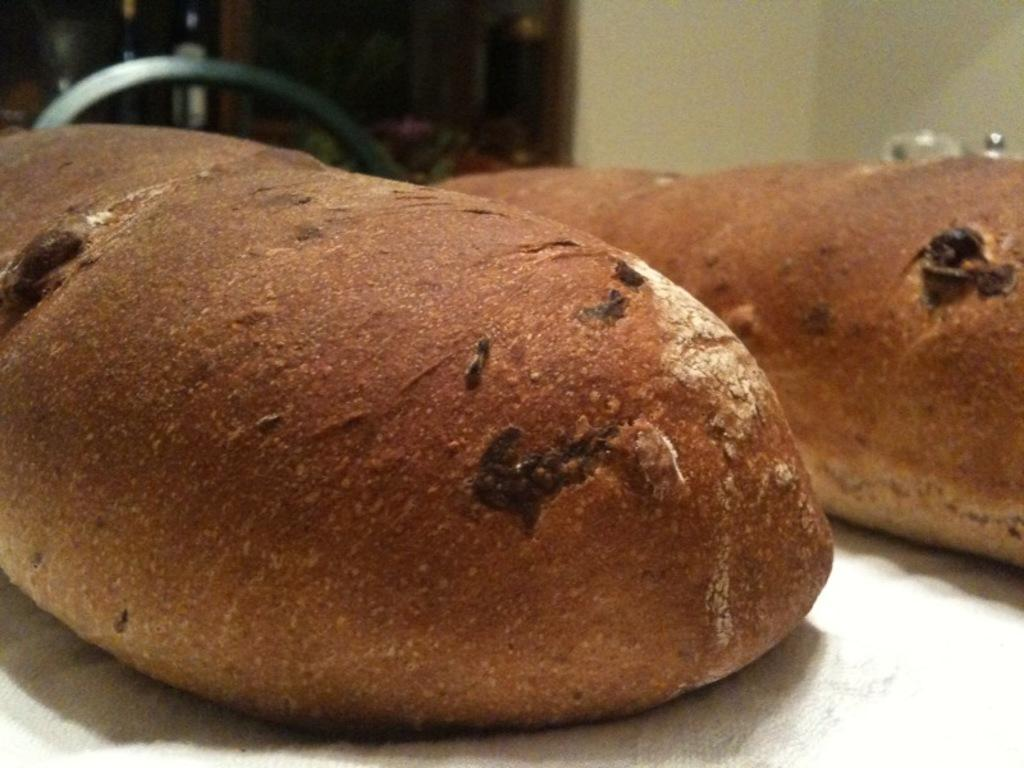What is the main subject in the center of the image? There is a white object in the center of the image. What is placed on the white object? There are food items on the white object. What can be seen in the background of the image? There is a wall and other objects visible in the background. Where is the bomb located in the image? There is no bomb present in the image. Which direction is the school located in the image? There is no school present in the image. 